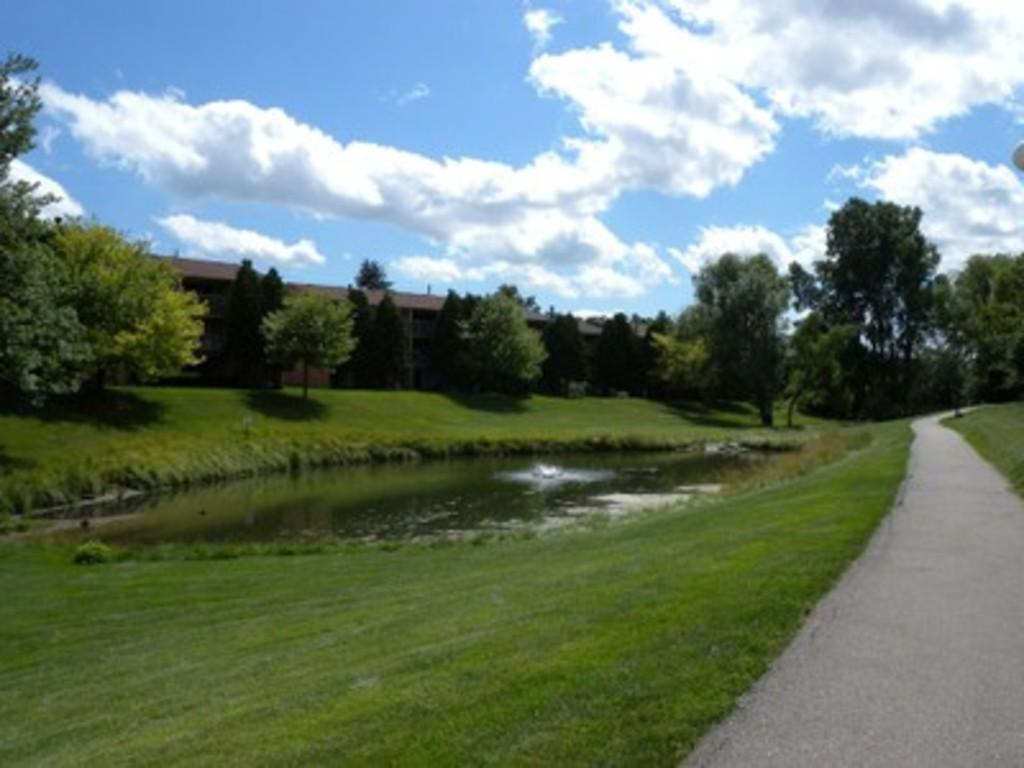What type of body of water is present in the image? There is a pond in the image. What type of vegetation can be seen in the image? There is grass and trees in the image. What type of structure is present in the image? There is a house with a roof in the image. What type of surface is present for walking in the image? There is a pathway in the image. What is the condition of the sky in the image? The sky is visible in the image and appears cloudy. Can you see any animals from the zoo in the image? There is no zoo or animals from a zoo present in the image. What type of tool is being used to fix the bun in the image? There is no bun or tool present in the image. 